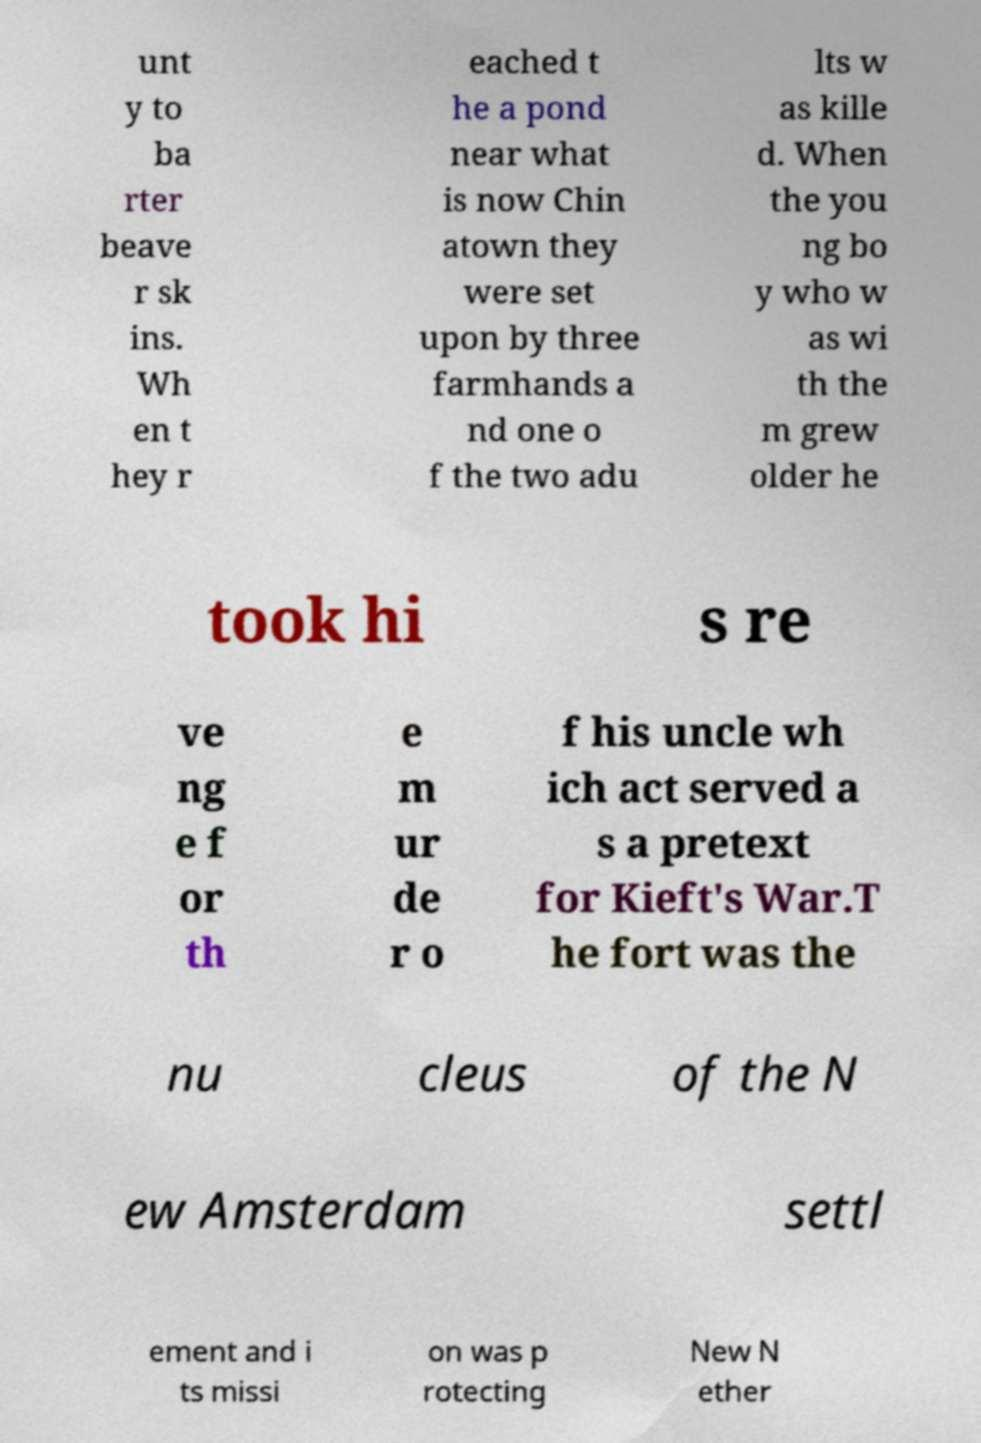Could you extract and type out the text from this image? unt y to ba rter beave r sk ins. Wh en t hey r eached t he a pond near what is now Chin atown they were set upon by three farmhands a nd one o f the two adu lts w as kille d. When the you ng bo y who w as wi th the m grew older he took hi s re ve ng e f or th e m ur de r o f his uncle wh ich act served a s a pretext for Kieft's War.T he fort was the nu cleus of the N ew Amsterdam settl ement and i ts missi on was p rotecting New N ether 